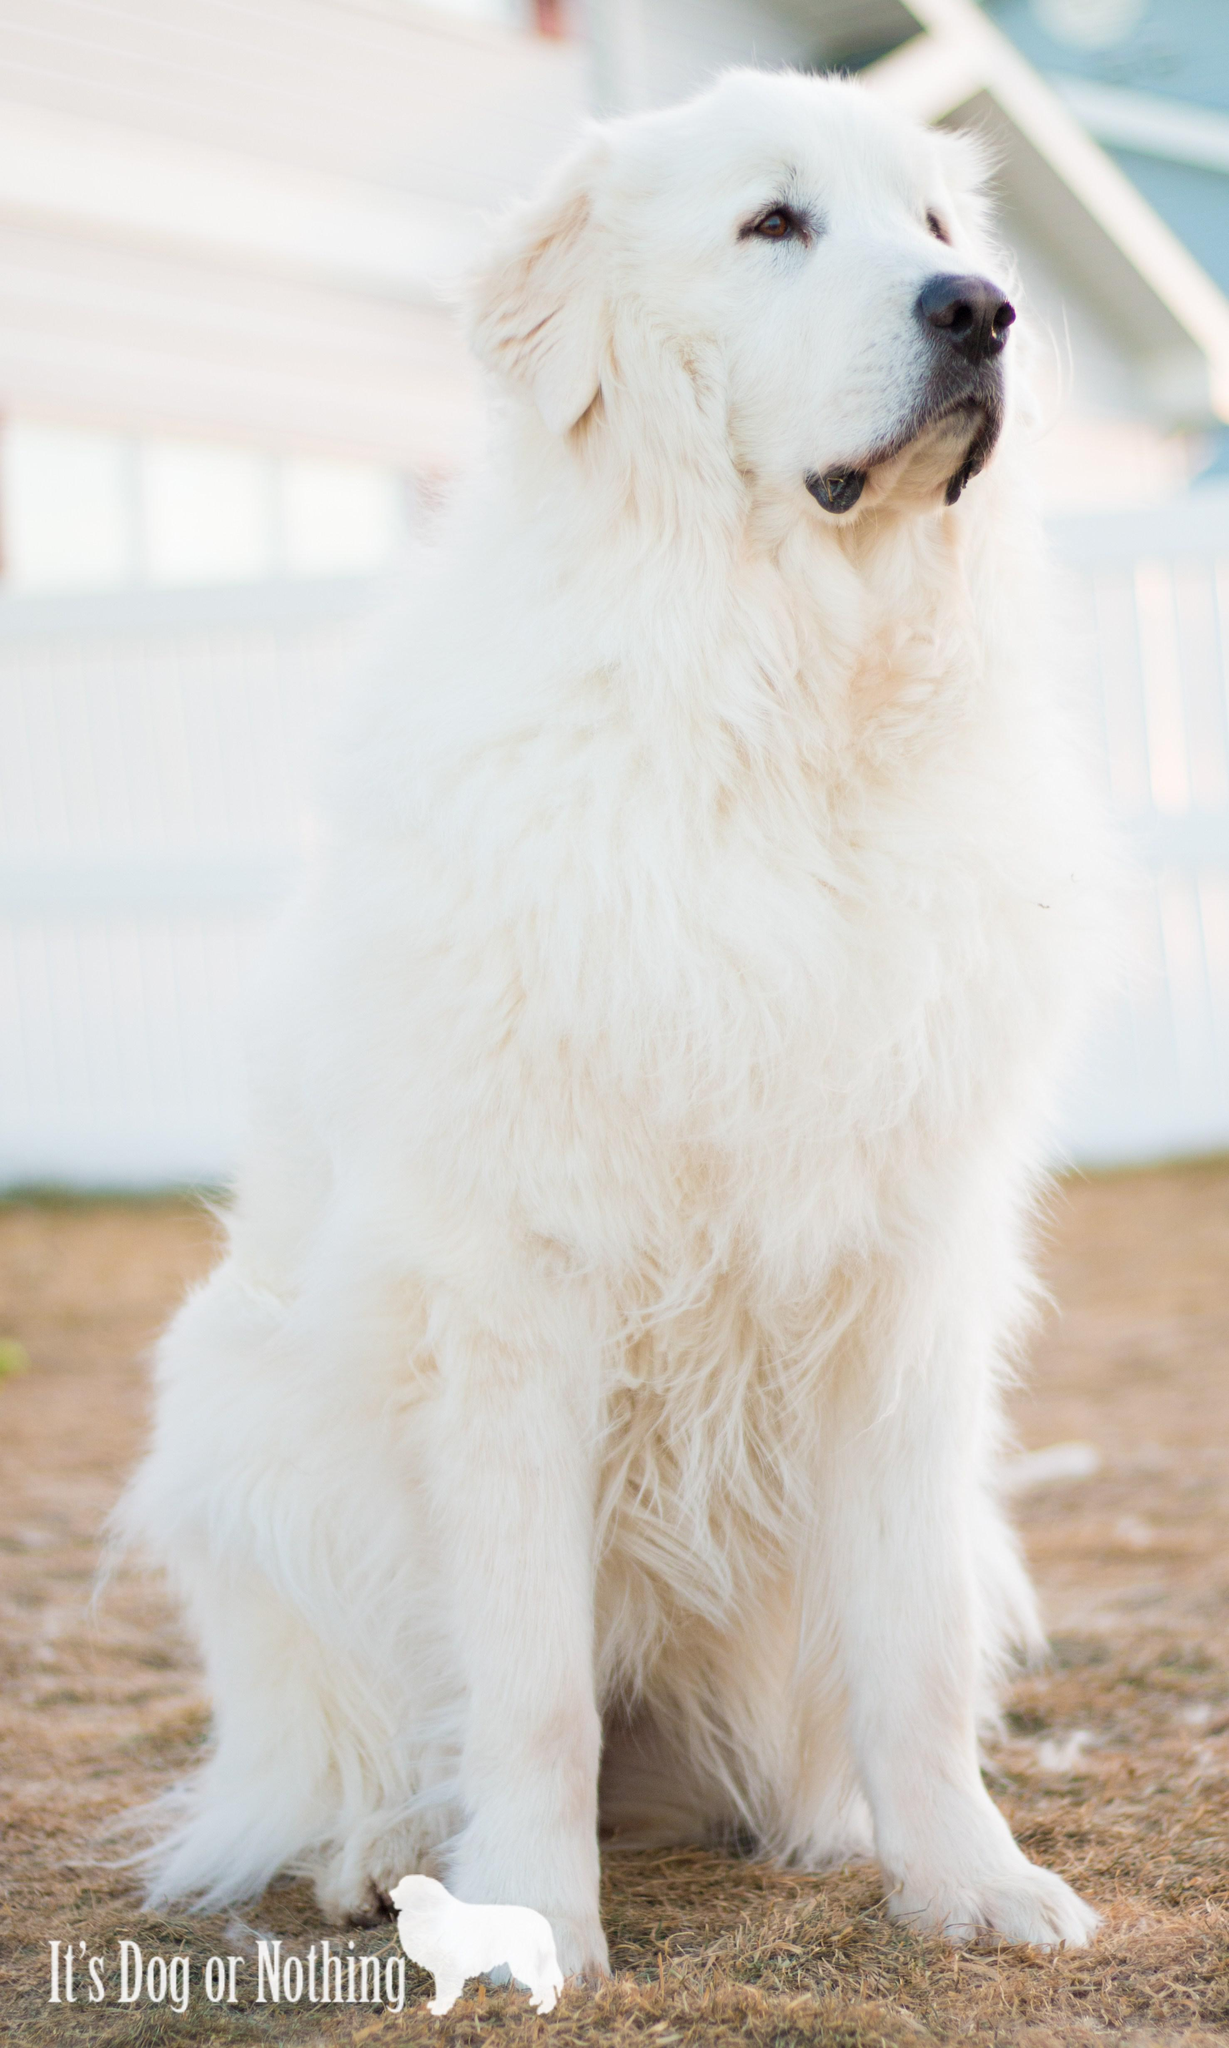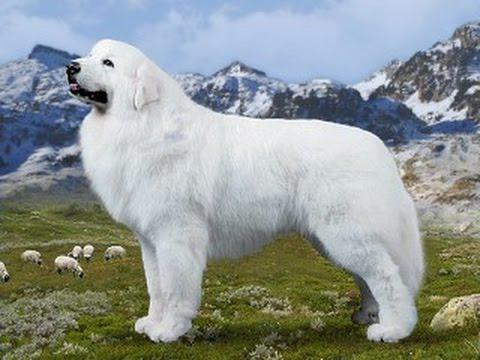The first image is the image on the left, the second image is the image on the right. Given the left and right images, does the statement "The dog on the right is standing in the grass." hold true? Answer yes or no. Yes. The first image is the image on the left, the second image is the image on the right. Considering the images on both sides, is "A large white dog, standing at an outdoor location, has its mouth open and is showing its tongue." valid? Answer yes or no. No. 